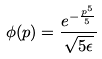Convert formula to latex. <formula><loc_0><loc_0><loc_500><loc_500>\phi ( p ) = \frac { e ^ { - \frac { p ^ { 5 } } { 5 } } } { \sqrt { 5 \epsilon } }</formula> 